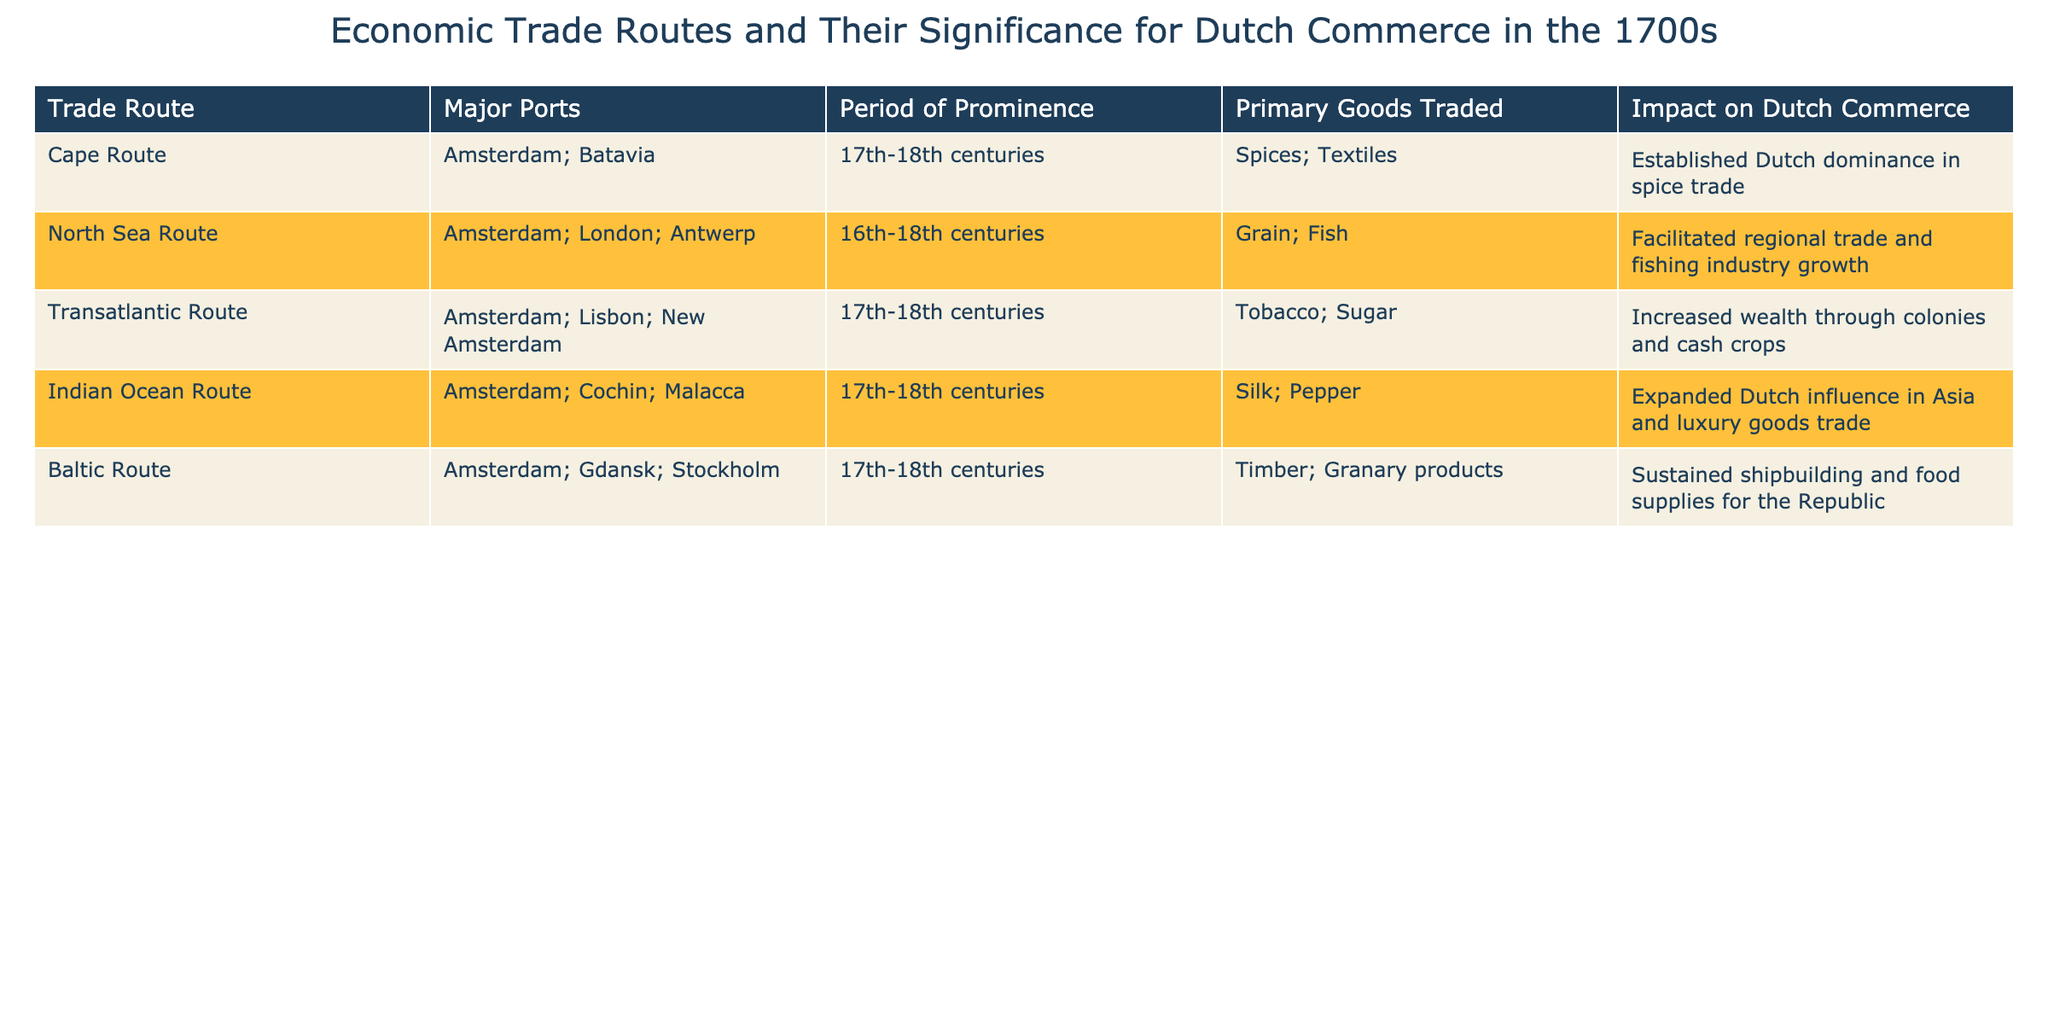What is the primary good traded on the Cape Route? The table specifies that the primary goods traded on the Cape Route include spices and textiles. By looking at the information directly under the "Primary Goods Traded" column for the Cape Route, we can conclude that spices is one of the main items.
Answer: Spices Which trade route had a period of prominence in the 16th to 18th centuries? From the "Period of Prominence" column, both the North Sea Route and Baltic Route are listed as being prominent from the 16th to the 18th centuries. Thus, they are the trade routes fitting this time frame.
Answer: North Sea Route; Baltic Route How many major ports are associated with the Transatlantic Route? According to the "Major Ports" column for the Transatlantic Route, three ports are mentioned: Amsterdam, Lisbon, and New Amsterdam. By counting these specific entries, we ascertain the total.
Answer: Three Did the Indian Ocean Route contribute to the expansion of Dutch influence in Asia? The table explicitly states that the Indian Ocean Route helped expand Dutch influence in Asia. Thus, the answer to this factual question is supported directly by information provided in the table.
Answer: Yes What is the average period of prominence for the trade routes listed in the table? The various trade routes have periods of prominence as follows: 2 routes for the 16th-18th centuries, and 3 routes for the 17th-18th centuries. To find the average, we consider the total duration of prominence across the various routes. By noting the overlapping periods, we can conclude that most are prominent over about 2 centuries. Therefore, the average could be roughly considered about 2 centuries given that the time spans overlap considerably.
Answer: 2 centuries Which trade route had the least impact on Dutch commerce? By reviewing the "Impact on Dutch Commerce" column, we can infer the significance of each route. All listed impacts are quite substantial and pivotal for commerce. Hence, this question requires a qualitative judgment. The Baltic Route is somewhat distinct as it primarily focused on sustaining local shipbuilding and food supplies rather than grand economic shifts, making it comparatively lesser in impact.
Answer: Baltic Route Which primary goods were traded on the North Sea Route? The “Primary Goods Traded” for the North Sea Route lists grain and fish. This can be easily retrieved by locating the corresponding row in the table.
Answer: Grain; Fish Was the Transatlantic Route more focused on luxury goods than the Indian Ocean Route? The Transatlantic Route emphasizes the trade of tobacco and sugar, which are cash crops, whereas the Indian Ocean Route focuses on silk and pepper, considered luxury goods. Comparing the primary goods traded indicates that the Indian Ocean Route had a more distinct focus on luxury items than the Transatlantic Route’s sugar and tobacco. Therefore, the factual answer is no.
Answer: No 